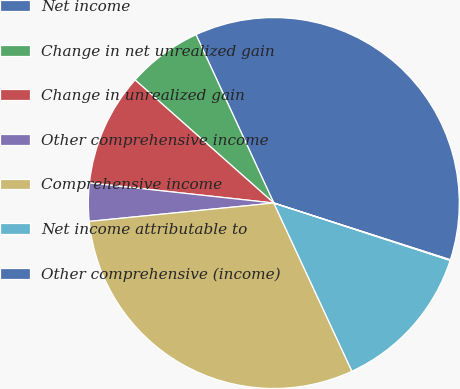<chart> <loc_0><loc_0><loc_500><loc_500><pie_chart><fcel>Net income<fcel>Change in net unrealized gain<fcel>Change in unrealized gain<fcel>Other comprehensive income<fcel>Comprehensive income<fcel>Net income attributable to<fcel>Other comprehensive (income)<nl><fcel>36.84%<fcel>6.56%<fcel>9.82%<fcel>3.31%<fcel>30.34%<fcel>13.07%<fcel>0.06%<nl></chart> 